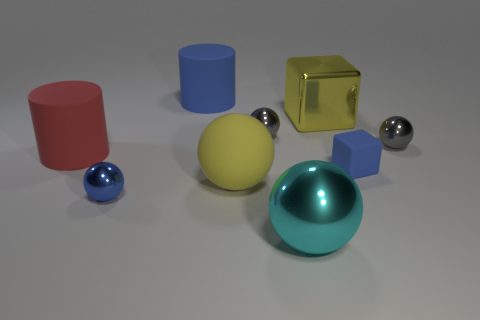Subtract all large yellow rubber balls. How many balls are left? 4 Subtract 1 spheres. How many spheres are left? 4 Subtract all cyan balls. How many balls are left? 4 Subtract all cyan spheres. Subtract all yellow cubes. How many spheres are left? 4 Add 1 gray metallic spheres. How many objects exist? 10 Subtract all cylinders. How many objects are left? 7 Subtract 2 gray spheres. How many objects are left? 7 Subtract all large yellow cubes. Subtract all small gray shiny objects. How many objects are left? 6 Add 5 tiny rubber objects. How many tiny rubber objects are left? 6 Add 3 blue metal balls. How many blue metal balls exist? 4 